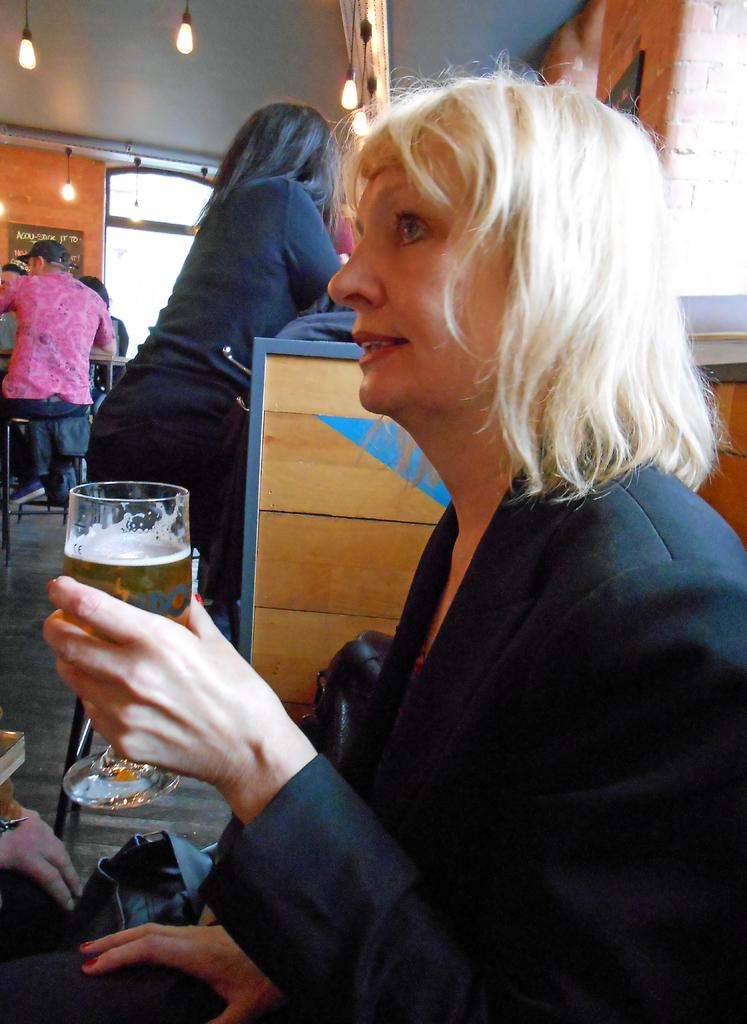What is the main subject of the image? The main subject of the image is a group of people. Can you describe what the woman is holding in the image? The woman is holding a glass with a drink. How are some of the people positioned in the image? Some people are sitting on chairs. What type of material is the wall in the image made of? The wall in the image is made of wood. What can be seen providing illumination in the image? There is a light visible in the image. Can you tell me how many beetles are crawling on the wooden wall in the image? There are no beetles present on the wooden wall in the image. What type of coil is being used by the people in the image? There is no coil visible in the image; the people are simply sitting on chairs. 